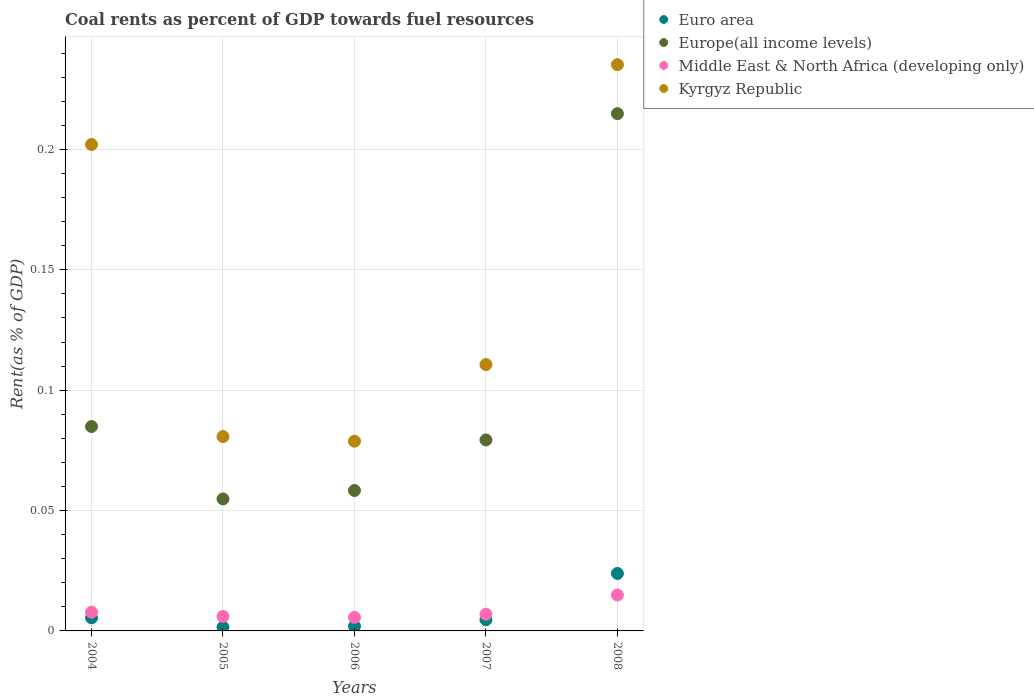Is the number of dotlines equal to the number of legend labels?
Provide a short and direct response. Yes. What is the coal rent in Middle East & North Africa (developing only) in 2005?
Provide a short and direct response. 0.01. Across all years, what is the maximum coal rent in Middle East & North Africa (developing only)?
Offer a terse response. 0.01. Across all years, what is the minimum coal rent in Euro area?
Keep it short and to the point. 0. What is the total coal rent in Middle East & North Africa (developing only) in the graph?
Provide a short and direct response. 0.04. What is the difference between the coal rent in Kyrgyz Republic in 2004 and that in 2007?
Offer a terse response. 0.09. What is the difference between the coal rent in Euro area in 2005 and the coal rent in Kyrgyz Republic in 2007?
Offer a very short reply. -0.11. What is the average coal rent in Kyrgyz Republic per year?
Keep it short and to the point. 0.14. In the year 2006, what is the difference between the coal rent in Europe(all income levels) and coal rent in Middle East & North Africa (developing only)?
Keep it short and to the point. 0.05. What is the ratio of the coal rent in Kyrgyz Republic in 2007 to that in 2008?
Ensure brevity in your answer.  0.47. Is the coal rent in Euro area in 2007 less than that in 2008?
Provide a short and direct response. Yes. Is the difference between the coal rent in Europe(all income levels) in 2005 and 2008 greater than the difference between the coal rent in Middle East & North Africa (developing only) in 2005 and 2008?
Give a very brief answer. No. What is the difference between the highest and the second highest coal rent in Kyrgyz Republic?
Your response must be concise. 0.03. What is the difference between the highest and the lowest coal rent in Middle East & North Africa (developing only)?
Offer a terse response. 0.01. Is it the case that in every year, the sum of the coal rent in Europe(all income levels) and coal rent in Middle East & North Africa (developing only)  is greater than the sum of coal rent in Kyrgyz Republic and coal rent in Euro area?
Give a very brief answer. Yes. Is it the case that in every year, the sum of the coal rent in Euro area and coal rent in Middle East & North Africa (developing only)  is greater than the coal rent in Kyrgyz Republic?
Your answer should be very brief. No. How many years are there in the graph?
Offer a terse response. 5. Are the values on the major ticks of Y-axis written in scientific E-notation?
Provide a succinct answer. No. Does the graph contain any zero values?
Your answer should be very brief. No. Where does the legend appear in the graph?
Ensure brevity in your answer.  Top right. How many legend labels are there?
Your response must be concise. 4. What is the title of the graph?
Provide a short and direct response. Coal rents as percent of GDP towards fuel resources. Does "Sub-Saharan Africa (all income levels)" appear as one of the legend labels in the graph?
Provide a succinct answer. No. What is the label or title of the X-axis?
Keep it short and to the point. Years. What is the label or title of the Y-axis?
Your answer should be compact. Rent(as % of GDP). What is the Rent(as % of GDP) of Euro area in 2004?
Provide a short and direct response. 0.01. What is the Rent(as % of GDP) of Europe(all income levels) in 2004?
Ensure brevity in your answer.  0.08. What is the Rent(as % of GDP) in Middle East & North Africa (developing only) in 2004?
Give a very brief answer. 0.01. What is the Rent(as % of GDP) of Kyrgyz Republic in 2004?
Your answer should be compact. 0.2. What is the Rent(as % of GDP) in Euro area in 2005?
Make the answer very short. 0. What is the Rent(as % of GDP) in Europe(all income levels) in 2005?
Keep it short and to the point. 0.05. What is the Rent(as % of GDP) of Middle East & North Africa (developing only) in 2005?
Offer a terse response. 0.01. What is the Rent(as % of GDP) in Kyrgyz Republic in 2005?
Offer a terse response. 0.08. What is the Rent(as % of GDP) of Euro area in 2006?
Make the answer very short. 0. What is the Rent(as % of GDP) of Europe(all income levels) in 2006?
Your response must be concise. 0.06. What is the Rent(as % of GDP) in Middle East & North Africa (developing only) in 2006?
Provide a short and direct response. 0.01. What is the Rent(as % of GDP) of Kyrgyz Republic in 2006?
Your answer should be compact. 0.08. What is the Rent(as % of GDP) of Euro area in 2007?
Your response must be concise. 0. What is the Rent(as % of GDP) in Europe(all income levels) in 2007?
Make the answer very short. 0.08. What is the Rent(as % of GDP) of Middle East & North Africa (developing only) in 2007?
Your answer should be very brief. 0.01. What is the Rent(as % of GDP) of Kyrgyz Republic in 2007?
Ensure brevity in your answer.  0.11. What is the Rent(as % of GDP) of Euro area in 2008?
Your answer should be compact. 0.02. What is the Rent(as % of GDP) in Europe(all income levels) in 2008?
Your answer should be compact. 0.21. What is the Rent(as % of GDP) of Middle East & North Africa (developing only) in 2008?
Give a very brief answer. 0.01. What is the Rent(as % of GDP) in Kyrgyz Republic in 2008?
Your answer should be very brief. 0.24. Across all years, what is the maximum Rent(as % of GDP) of Euro area?
Ensure brevity in your answer.  0.02. Across all years, what is the maximum Rent(as % of GDP) in Europe(all income levels)?
Provide a succinct answer. 0.21. Across all years, what is the maximum Rent(as % of GDP) of Middle East & North Africa (developing only)?
Offer a very short reply. 0.01. Across all years, what is the maximum Rent(as % of GDP) in Kyrgyz Republic?
Ensure brevity in your answer.  0.24. Across all years, what is the minimum Rent(as % of GDP) in Euro area?
Offer a very short reply. 0. Across all years, what is the minimum Rent(as % of GDP) in Europe(all income levels)?
Your response must be concise. 0.05. Across all years, what is the minimum Rent(as % of GDP) of Middle East & North Africa (developing only)?
Provide a short and direct response. 0.01. Across all years, what is the minimum Rent(as % of GDP) of Kyrgyz Republic?
Give a very brief answer. 0.08. What is the total Rent(as % of GDP) in Euro area in the graph?
Provide a succinct answer. 0.04. What is the total Rent(as % of GDP) of Europe(all income levels) in the graph?
Offer a very short reply. 0.49. What is the total Rent(as % of GDP) of Middle East & North Africa (developing only) in the graph?
Provide a succinct answer. 0.04. What is the total Rent(as % of GDP) of Kyrgyz Republic in the graph?
Ensure brevity in your answer.  0.71. What is the difference between the Rent(as % of GDP) in Euro area in 2004 and that in 2005?
Your answer should be very brief. 0. What is the difference between the Rent(as % of GDP) of Europe(all income levels) in 2004 and that in 2005?
Your answer should be compact. 0.03. What is the difference between the Rent(as % of GDP) in Middle East & North Africa (developing only) in 2004 and that in 2005?
Your response must be concise. 0. What is the difference between the Rent(as % of GDP) in Kyrgyz Republic in 2004 and that in 2005?
Ensure brevity in your answer.  0.12. What is the difference between the Rent(as % of GDP) in Euro area in 2004 and that in 2006?
Your answer should be very brief. 0. What is the difference between the Rent(as % of GDP) of Europe(all income levels) in 2004 and that in 2006?
Provide a succinct answer. 0.03. What is the difference between the Rent(as % of GDP) of Middle East & North Africa (developing only) in 2004 and that in 2006?
Offer a very short reply. 0. What is the difference between the Rent(as % of GDP) of Kyrgyz Republic in 2004 and that in 2006?
Offer a very short reply. 0.12. What is the difference between the Rent(as % of GDP) in Euro area in 2004 and that in 2007?
Provide a short and direct response. 0. What is the difference between the Rent(as % of GDP) in Europe(all income levels) in 2004 and that in 2007?
Give a very brief answer. 0.01. What is the difference between the Rent(as % of GDP) of Middle East & North Africa (developing only) in 2004 and that in 2007?
Make the answer very short. 0. What is the difference between the Rent(as % of GDP) of Kyrgyz Republic in 2004 and that in 2007?
Give a very brief answer. 0.09. What is the difference between the Rent(as % of GDP) of Euro area in 2004 and that in 2008?
Offer a terse response. -0.02. What is the difference between the Rent(as % of GDP) of Europe(all income levels) in 2004 and that in 2008?
Your response must be concise. -0.13. What is the difference between the Rent(as % of GDP) of Middle East & North Africa (developing only) in 2004 and that in 2008?
Your response must be concise. -0.01. What is the difference between the Rent(as % of GDP) in Kyrgyz Republic in 2004 and that in 2008?
Ensure brevity in your answer.  -0.03. What is the difference between the Rent(as % of GDP) in Euro area in 2005 and that in 2006?
Your answer should be very brief. -0. What is the difference between the Rent(as % of GDP) in Europe(all income levels) in 2005 and that in 2006?
Your answer should be compact. -0. What is the difference between the Rent(as % of GDP) in Kyrgyz Republic in 2005 and that in 2006?
Provide a short and direct response. 0. What is the difference between the Rent(as % of GDP) of Euro area in 2005 and that in 2007?
Your answer should be very brief. -0. What is the difference between the Rent(as % of GDP) in Europe(all income levels) in 2005 and that in 2007?
Offer a terse response. -0.02. What is the difference between the Rent(as % of GDP) in Middle East & North Africa (developing only) in 2005 and that in 2007?
Your answer should be very brief. -0. What is the difference between the Rent(as % of GDP) in Kyrgyz Republic in 2005 and that in 2007?
Provide a short and direct response. -0.03. What is the difference between the Rent(as % of GDP) of Euro area in 2005 and that in 2008?
Give a very brief answer. -0.02. What is the difference between the Rent(as % of GDP) of Europe(all income levels) in 2005 and that in 2008?
Keep it short and to the point. -0.16. What is the difference between the Rent(as % of GDP) in Middle East & North Africa (developing only) in 2005 and that in 2008?
Provide a succinct answer. -0.01. What is the difference between the Rent(as % of GDP) of Kyrgyz Republic in 2005 and that in 2008?
Provide a short and direct response. -0.15. What is the difference between the Rent(as % of GDP) of Euro area in 2006 and that in 2007?
Ensure brevity in your answer.  -0. What is the difference between the Rent(as % of GDP) of Europe(all income levels) in 2006 and that in 2007?
Offer a terse response. -0.02. What is the difference between the Rent(as % of GDP) in Middle East & North Africa (developing only) in 2006 and that in 2007?
Provide a succinct answer. -0. What is the difference between the Rent(as % of GDP) of Kyrgyz Republic in 2006 and that in 2007?
Your answer should be compact. -0.03. What is the difference between the Rent(as % of GDP) of Euro area in 2006 and that in 2008?
Give a very brief answer. -0.02. What is the difference between the Rent(as % of GDP) in Europe(all income levels) in 2006 and that in 2008?
Your answer should be very brief. -0.16. What is the difference between the Rent(as % of GDP) of Middle East & North Africa (developing only) in 2006 and that in 2008?
Provide a short and direct response. -0.01. What is the difference between the Rent(as % of GDP) in Kyrgyz Republic in 2006 and that in 2008?
Make the answer very short. -0.16. What is the difference between the Rent(as % of GDP) of Euro area in 2007 and that in 2008?
Offer a very short reply. -0.02. What is the difference between the Rent(as % of GDP) of Europe(all income levels) in 2007 and that in 2008?
Give a very brief answer. -0.14. What is the difference between the Rent(as % of GDP) in Middle East & North Africa (developing only) in 2007 and that in 2008?
Your response must be concise. -0.01. What is the difference between the Rent(as % of GDP) of Kyrgyz Republic in 2007 and that in 2008?
Your answer should be very brief. -0.12. What is the difference between the Rent(as % of GDP) of Euro area in 2004 and the Rent(as % of GDP) of Europe(all income levels) in 2005?
Your response must be concise. -0.05. What is the difference between the Rent(as % of GDP) of Euro area in 2004 and the Rent(as % of GDP) of Middle East & North Africa (developing only) in 2005?
Offer a terse response. -0. What is the difference between the Rent(as % of GDP) in Euro area in 2004 and the Rent(as % of GDP) in Kyrgyz Republic in 2005?
Keep it short and to the point. -0.08. What is the difference between the Rent(as % of GDP) of Europe(all income levels) in 2004 and the Rent(as % of GDP) of Middle East & North Africa (developing only) in 2005?
Provide a succinct answer. 0.08. What is the difference between the Rent(as % of GDP) in Europe(all income levels) in 2004 and the Rent(as % of GDP) in Kyrgyz Republic in 2005?
Ensure brevity in your answer.  0. What is the difference between the Rent(as % of GDP) in Middle East & North Africa (developing only) in 2004 and the Rent(as % of GDP) in Kyrgyz Republic in 2005?
Provide a succinct answer. -0.07. What is the difference between the Rent(as % of GDP) in Euro area in 2004 and the Rent(as % of GDP) in Europe(all income levels) in 2006?
Make the answer very short. -0.05. What is the difference between the Rent(as % of GDP) in Euro area in 2004 and the Rent(as % of GDP) in Middle East & North Africa (developing only) in 2006?
Make the answer very short. -0. What is the difference between the Rent(as % of GDP) of Euro area in 2004 and the Rent(as % of GDP) of Kyrgyz Republic in 2006?
Offer a very short reply. -0.07. What is the difference between the Rent(as % of GDP) in Europe(all income levels) in 2004 and the Rent(as % of GDP) in Middle East & North Africa (developing only) in 2006?
Make the answer very short. 0.08. What is the difference between the Rent(as % of GDP) of Europe(all income levels) in 2004 and the Rent(as % of GDP) of Kyrgyz Republic in 2006?
Offer a terse response. 0.01. What is the difference between the Rent(as % of GDP) of Middle East & North Africa (developing only) in 2004 and the Rent(as % of GDP) of Kyrgyz Republic in 2006?
Offer a terse response. -0.07. What is the difference between the Rent(as % of GDP) of Euro area in 2004 and the Rent(as % of GDP) of Europe(all income levels) in 2007?
Keep it short and to the point. -0.07. What is the difference between the Rent(as % of GDP) in Euro area in 2004 and the Rent(as % of GDP) in Middle East & North Africa (developing only) in 2007?
Your answer should be very brief. -0. What is the difference between the Rent(as % of GDP) of Euro area in 2004 and the Rent(as % of GDP) of Kyrgyz Republic in 2007?
Your response must be concise. -0.11. What is the difference between the Rent(as % of GDP) in Europe(all income levels) in 2004 and the Rent(as % of GDP) in Middle East & North Africa (developing only) in 2007?
Keep it short and to the point. 0.08. What is the difference between the Rent(as % of GDP) in Europe(all income levels) in 2004 and the Rent(as % of GDP) in Kyrgyz Republic in 2007?
Keep it short and to the point. -0.03. What is the difference between the Rent(as % of GDP) in Middle East & North Africa (developing only) in 2004 and the Rent(as % of GDP) in Kyrgyz Republic in 2007?
Offer a terse response. -0.1. What is the difference between the Rent(as % of GDP) of Euro area in 2004 and the Rent(as % of GDP) of Europe(all income levels) in 2008?
Provide a short and direct response. -0.21. What is the difference between the Rent(as % of GDP) of Euro area in 2004 and the Rent(as % of GDP) of Middle East & North Africa (developing only) in 2008?
Your answer should be very brief. -0.01. What is the difference between the Rent(as % of GDP) of Euro area in 2004 and the Rent(as % of GDP) of Kyrgyz Republic in 2008?
Make the answer very short. -0.23. What is the difference between the Rent(as % of GDP) in Europe(all income levels) in 2004 and the Rent(as % of GDP) in Middle East & North Africa (developing only) in 2008?
Ensure brevity in your answer.  0.07. What is the difference between the Rent(as % of GDP) in Europe(all income levels) in 2004 and the Rent(as % of GDP) in Kyrgyz Republic in 2008?
Provide a succinct answer. -0.15. What is the difference between the Rent(as % of GDP) in Middle East & North Africa (developing only) in 2004 and the Rent(as % of GDP) in Kyrgyz Republic in 2008?
Offer a very short reply. -0.23. What is the difference between the Rent(as % of GDP) in Euro area in 2005 and the Rent(as % of GDP) in Europe(all income levels) in 2006?
Your answer should be very brief. -0.06. What is the difference between the Rent(as % of GDP) of Euro area in 2005 and the Rent(as % of GDP) of Middle East & North Africa (developing only) in 2006?
Your response must be concise. -0. What is the difference between the Rent(as % of GDP) of Euro area in 2005 and the Rent(as % of GDP) of Kyrgyz Republic in 2006?
Provide a short and direct response. -0.08. What is the difference between the Rent(as % of GDP) in Europe(all income levels) in 2005 and the Rent(as % of GDP) in Middle East & North Africa (developing only) in 2006?
Your answer should be very brief. 0.05. What is the difference between the Rent(as % of GDP) in Europe(all income levels) in 2005 and the Rent(as % of GDP) in Kyrgyz Republic in 2006?
Ensure brevity in your answer.  -0.02. What is the difference between the Rent(as % of GDP) of Middle East & North Africa (developing only) in 2005 and the Rent(as % of GDP) of Kyrgyz Republic in 2006?
Offer a very short reply. -0.07. What is the difference between the Rent(as % of GDP) of Euro area in 2005 and the Rent(as % of GDP) of Europe(all income levels) in 2007?
Offer a very short reply. -0.08. What is the difference between the Rent(as % of GDP) in Euro area in 2005 and the Rent(as % of GDP) in Middle East & North Africa (developing only) in 2007?
Ensure brevity in your answer.  -0.01. What is the difference between the Rent(as % of GDP) of Euro area in 2005 and the Rent(as % of GDP) of Kyrgyz Republic in 2007?
Provide a succinct answer. -0.11. What is the difference between the Rent(as % of GDP) of Europe(all income levels) in 2005 and the Rent(as % of GDP) of Middle East & North Africa (developing only) in 2007?
Your answer should be very brief. 0.05. What is the difference between the Rent(as % of GDP) in Europe(all income levels) in 2005 and the Rent(as % of GDP) in Kyrgyz Republic in 2007?
Ensure brevity in your answer.  -0.06. What is the difference between the Rent(as % of GDP) of Middle East & North Africa (developing only) in 2005 and the Rent(as % of GDP) of Kyrgyz Republic in 2007?
Keep it short and to the point. -0.1. What is the difference between the Rent(as % of GDP) in Euro area in 2005 and the Rent(as % of GDP) in Europe(all income levels) in 2008?
Keep it short and to the point. -0.21. What is the difference between the Rent(as % of GDP) of Euro area in 2005 and the Rent(as % of GDP) of Middle East & North Africa (developing only) in 2008?
Provide a short and direct response. -0.01. What is the difference between the Rent(as % of GDP) of Euro area in 2005 and the Rent(as % of GDP) of Kyrgyz Republic in 2008?
Your answer should be compact. -0.23. What is the difference between the Rent(as % of GDP) of Europe(all income levels) in 2005 and the Rent(as % of GDP) of Middle East & North Africa (developing only) in 2008?
Make the answer very short. 0.04. What is the difference between the Rent(as % of GDP) in Europe(all income levels) in 2005 and the Rent(as % of GDP) in Kyrgyz Republic in 2008?
Offer a very short reply. -0.18. What is the difference between the Rent(as % of GDP) in Middle East & North Africa (developing only) in 2005 and the Rent(as % of GDP) in Kyrgyz Republic in 2008?
Offer a terse response. -0.23. What is the difference between the Rent(as % of GDP) in Euro area in 2006 and the Rent(as % of GDP) in Europe(all income levels) in 2007?
Offer a terse response. -0.08. What is the difference between the Rent(as % of GDP) of Euro area in 2006 and the Rent(as % of GDP) of Middle East & North Africa (developing only) in 2007?
Provide a succinct answer. -0.01. What is the difference between the Rent(as % of GDP) in Euro area in 2006 and the Rent(as % of GDP) in Kyrgyz Republic in 2007?
Keep it short and to the point. -0.11. What is the difference between the Rent(as % of GDP) of Europe(all income levels) in 2006 and the Rent(as % of GDP) of Middle East & North Africa (developing only) in 2007?
Your response must be concise. 0.05. What is the difference between the Rent(as % of GDP) of Europe(all income levels) in 2006 and the Rent(as % of GDP) of Kyrgyz Republic in 2007?
Give a very brief answer. -0.05. What is the difference between the Rent(as % of GDP) in Middle East & North Africa (developing only) in 2006 and the Rent(as % of GDP) in Kyrgyz Republic in 2007?
Make the answer very short. -0.1. What is the difference between the Rent(as % of GDP) of Euro area in 2006 and the Rent(as % of GDP) of Europe(all income levels) in 2008?
Keep it short and to the point. -0.21. What is the difference between the Rent(as % of GDP) of Euro area in 2006 and the Rent(as % of GDP) of Middle East & North Africa (developing only) in 2008?
Provide a short and direct response. -0.01. What is the difference between the Rent(as % of GDP) in Euro area in 2006 and the Rent(as % of GDP) in Kyrgyz Republic in 2008?
Give a very brief answer. -0.23. What is the difference between the Rent(as % of GDP) of Europe(all income levels) in 2006 and the Rent(as % of GDP) of Middle East & North Africa (developing only) in 2008?
Offer a terse response. 0.04. What is the difference between the Rent(as % of GDP) of Europe(all income levels) in 2006 and the Rent(as % of GDP) of Kyrgyz Republic in 2008?
Offer a very short reply. -0.18. What is the difference between the Rent(as % of GDP) of Middle East & North Africa (developing only) in 2006 and the Rent(as % of GDP) of Kyrgyz Republic in 2008?
Your answer should be very brief. -0.23. What is the difference between the Rent(as % of GDP) of Euro area in 2007 and the Rent(as % of GDP) of Europe(all income levels) in 2008?
Offer a terse response. -0.21. What is the difference between the Rent(as % of GDP) of Euro area in 2007 and the Rent(as % of GDP) of Middle East & North Africa (developing only) in 2008?
Provide a short and direct response. -0.01. What is the difference between the Rent(as % of GDP) in Euro area in 2007 and the Rent(as % of GDP) in Kyrgyz Republic in 2008?
Give a very brief answer. -0.23. What is the difference between the Rent(as % of GDP) of Europe(all income levels) in 2007 and the Rent(as % of GDP) of Middle East & North Africa (developing only) in 2008?
Provide a short and direct response. 0.06. What is the difference between the Rent(as % of GDP) of Europe(all income levels) in 2007 and the Rent(as % of GDP) of Kyrgyz Republic in 2008?
Offer a very short reply. -0.16. What is the difference between the Rent(as % of GDP) in Middle East & North Africa (developing only) in 2007 and the Rent(as % of GDP) in Kyrgyz Republic in 2008?
Provide a short and direct response. -0.23. What is the average Rent(as % of GDP) of Euro area per year?
Offer a terse response. 0.01. What is the average Rent(as % of GDP) of Europe(all income levels) per year?
Your response must be concise. 0.1. What is the average Rent(as % of GDP) in Middle East & North Africa (developing only) per year?
Keep it short and to the point. 0.01. What is the average Rent(as % of GDP) of Kyrgyz Republic per year?
Offer a terse response. 0.14. In the year 2004, what is the difference between the Rent(as % of GDP) in Euro area and Rent(as % of GDP) in Europe(all income levels)?
Make the answer very short. -0.08. In the year 2004, what is the difference between the Rent(as % of GDP) of Euro area and Rent(as % of GDP) of Middle East & North Africa (developing only)?
Keep it short and to the point. -0. In the year 2004, what is the difference between the Rent(as % of GDP) of Euro area and Rent(as % of GDP) of Kyrgyz Republic?
Keep it short and to the point. -0.2. In the year 2004, what is the difference between the Rent(as % of GDP) in Europe(all income levels) and Rent(as % of GDP) in Middle East & North Africa (developing only)?
Offer a very short reply. 0.08. In the year 2004, what is the difference between the Rent(as % of GDP) of Europe(all income levels) and Rent(as % of GDP) of Kyrgyz Republic?
Provide a short and direct response. -0.12. In the year 2004, what is the difference between the Rent(as % of GDP) of Middle East & North Africa (developing only) and Rent(as % of GDP) of Kyrgyz Republic?
Your response must be concise. -0.19. In the year 2005, what is the difference between the Rent(as % of GDP) of Euro area and Rent(as % of GDP) of Europe(all income levels)?
Ensure brevity in your answer.  -0.05. In the year 2005, what is the difference between the Rent(as % of GDP) in Euro area and Rent(as % of GDP) in Middle East & North Africa (developing only)?
Offer a very short reply. -0. In the year 2005, what is the difference between the Rent(as % of GDP) of Euro area and Rent(as % of GDP) of Kyrgyz Republic?
Keep it short and to the point. -0.08. In the year 2005, what is the difference between the Rent(as % of GDP) in Europe(all income levels) and Rent(as % of GDP) in Middle East & North Africa (developing only)?
Make the answer very short. 0.05. In the year 2005, what is the difference between the Rent(as % of GDP) in Europe(all income levels) and Rent(as % of GDP) in Kyrgyz Republic?
Your answer should be very brief. -0.03. In the year 2005, what is the difference between the Rent(as % of GDP) in Middle East & North Africa (developing only) and Rent(as % of GDP) in Kyrgyz Republic?
Keep it short and to the point. -0.07. In the year 2006, what is the difference between the Rent(as % of GDP) of Euro area and Rent(as % of GDP) of Europe(all income levels)?
Offer a terse response. -0.06. In the year 2006, what is the difference between the Rent(as % of GDP) in Euro area and Rent(as % of GDP) in Middle East & North Africa (developing only)?
Provide a succinct answer. -0. In the year 2006, what is the difference between the Rent(as % of GDP) in Euro area and Rent(as % of GDP) in Kyrgyz Republic?
Make the answer very short. -0.08. In the year 2006, what is the difference between the Rent(as % of GDP) in Europe(all income levels) and Rent(as % of GDP) in Middle East & North Africa (developing only)?
Provide a succinct answer. 0.05. In the year 2006, what is the difference between the Rent(as % of GDP) of Europe(all income levels) and Rent(as % of GDP) of Kyrgyz Republic?
Keep it short and to the point. -0.02. In the year 2006, what is the difference between the Rent(as % of GDP) of Middle East & North Africa (developing only) and Rent(as % of GDP) of Kyrgyz Republic?
Your answer should be compact. -0.07. In the year 2007, what is the difference between the Rent(as % of GDP) of Euro area and Rent(as % of GDP) of Europe(all income levels)?
Offer a terse response. -0.07. In the year 2007, what is the difference between the Rent(as % of GDP) of Euro area and Rent(as % of GDP) of Middle East & North Africa (developing only)?
Provide a short and direct response. -0. In the year 2007, what is the difference between the Rent(as % of GDP) of Euro area and Rent(as % of GDP) of Kyrgyz Republic?
Give a very brief answer. -0.11. In the year 2007, what is the difference between the Rent(as % of GDP) in Europe(all income levels) and Rent(as % of GDP) in Middle East & North Africa (developing only)?
Make the answer very short. 0.07. In the year 2007, what is the difference between the Rent(as % of GDP) of Europe(all income levels) and Rent(as % of GDP) of Kyrgyz Republic?
Offer a very short reply. -0.03. In the year 2007, what is the difference between the Rent(as % of GDP) of Middle East & North Africa (developing only) and Rent(as % of GDP) of Kyrgyz Republic?
Your response must be concise. -0.1. In the year 2008, what is the difference between the Rent(as % of GDP) of Euro area and Rent(as % of GDP) of Europe(all income levels)?
Your response must be concise. -0.19. In the year 2008, what is the difference between the Rent(as % of GDP) of Euro area and Rent(as % of GDP) of Middle East & North Africa (developing only)?
Keep it short and to the point. 0.01. In the year 2008, what is the difference between the Rent(as % of GDP) in Euro area and Rent(as % of GDP) in Kyrgyz Republic?
Your answer should be compact. -0.21. In the year 2008, what is the difference between the Rent(as % of GDP) in Europe(all income levels) and Rent(as % of GDP) in Middle East & North Africa (developing only)?
Give a very brief answer. 0.2. In the year 2008, what is the difference between the Rent(as % of GDP) of Europe(all income levels) and Rent(as % of GDP) of Kyrgyz Republic?
Ensure brevity in your answer.  -0.02. In the year 2008, what is the difference between the Rent(as % of GDP) in Middle East & North Africa (developing only) and Rent(as % of GDP) in Kyrgyz Republic?
Ensure brevity in your answer.  -0.22. What is the ratio of the Rent(as % of GDP) in Euro area in 2004 to that in 2005?
Provide a short and direct response. 3.44. What is the ratio of the Rent(as % of GDP) in Europe(all income levels) in 2004 to that in 2005?
Your response must be concise. 1.55. What is the ratio of the Rent(as % of GDP) of Middle East & North Africa (developing only) in 2004 to that in 2005?
Your answer should be compact. 1.29. What is the ratio of the Rent(as % of GDP) in Kyrgyz Republic in 2004 to that in 2005?
Your answer should be very brief. 2.5. What is the ratio of the Rent(as % of GDP) of Euro area in 2004 to that in 2006?
Provide a short and direct response. 2.81. What is the ratio of the Rent(as % of GDP) of Europe(all income levels) in 2004 to that in 2006?
Your response must be concise. 1.46. What is the ratio of the Rent(as % of GDP) of Middle East & North Africa (developing only) in 2004 to that in 2006?
Your answer should be compact. 1.39. What is the ratio of the Rent(as % of GDP) of Kyrgyz Republic in 2004 to that in 2006?
Make the answer very short. 2.56. What is the ratio of the Rent(as % of GDP) of Euro area in 2004 to that in 2007?
Give a very brief answer. 1.16. What is the ratio of the Rent(as % of GDP) of Europe(all income levels) in 2004 to that in 2007?
Provide a succinct answer. 1.07. What is the ratio of the Rent(as % of GDP) in Middle East & North Africa (developing only) in 2004 to that in 2007?
Give a very brief answer. 1.12. What is the ratio of the Rent(as % of GDP) in Kyrgyz Republic in 2004 to that in 2007?
Give a very brief answer. 1.83. What is the ratio of the Rent(as % of GDP) in Euro area in 2004 to that in 2008?
Keep it short and to the point. 0.23. What is the ratio of the Rent(as % of GDP) of Europe(all income levels) in 2004 to that in 2008?
Provide a short and direct response. 0.4. What is the ratio of the Rent(as % of GDP) of Middle East & North Africa (developing only) in 2004 to that in 2008?
Ensure brevity in your answer.  0.52. What is the ratio of the Rent(as % of GDP) of Kyrgyz Republic in 2004 to that in 2008?
Your response must be concise. 0.86. What is the ratio of the Rent(as % of GDP) in Euro area in 2005 to that in 2006?
Provide a succinct answer. 0.82. What is the ratio of the Rent(as % of GDP) in Europe(all income levels) in 2005 to that in 2006?
Provide a short and direct response. 0.94. What is the ratio of the Rent(as % of GDP) in Middle East & North Africa (developing only) in 2005 to that in 2006?
Your answer should be compact. 1.07. What is the ratio of the Rent(as % of GDP) in Kyrgyz Republic in 2005 to that in 2006?
Your answer should be very brief. 1.02. What is the ratio of the Rent(as % of GDP) in Euro area in 2005 to that in 2007?
Provide a short and direct response. 0.34. What is the ratio of the Rent(as % of GDP) in Europe(all income levels) in 2005 to that in 2007?
Make the answer very short. 0.69. What is the ratio of the Rent(as % of GDP) of Middle East & North Africa (developing only) in 2005 to that in 2007?
Your answer should be compact. 0.87. What is the ratio of the Rent(as % of GDP) in Kyrgyz Republic in 2005 to that in 2007?
Your answer should be compact. 0.73. What is the ratio of the Rent(as % of GDP) in Euro area in 2005 to that in 2008?
Ensure brevity in your answer.  0.07. What is the ratio of the Rent(as % of GDP) of Europe(all income levels) in 2005 to that in 2008?
Ensure brevity in your answer.  0.26. What is the ratio of the Rent(as % of GDP) in Middle East & North Africa (developing only) in 2005 to that in 2008?
Your answer should be very brief. 0.4. What is the ratio of the Rent(as % of GDP) of Kyrgyz Republic in 2005 to that in 2008?
Make the answer very short. 0.34. What is the ratio of the Rent(as % of GDP) in Euro area in 2006 to that in 2007?
Your answer should be very brief. 0.41. What is the ratio of the Rent(as % of GDP) of Europe(all income levels) in 2006 to that in 2007?
Your response must be concise. 0.74. What is the ratio of the Rent(as % of GDP) of Middle East & North Africa (developing only) in 2006 to that in 2007?
Keep it short and to the point. 0.81. What is the ratio of the Rent(as % of GDP) in Kyrgyz Republic in 2006 to that in 2007?
Provide a succinct answer. 0.71. What is the ratio of the Rent(as % of GDP) of Euro area in 2006 to that in 2008?
Give a very brief answer. 0.08. What is the ratio of the Rent(as % of GDP) of Europe(all income levels) in 2006 to that in 2008?
Provide a short and direct response. 0.27. What is the ratio of the Rent(as % of GDP) in Middle East & North Africa (developing only) in 2006 to that in 2008?
Give a very brief answer. 0.38. What is the ratio of the Rent(as % of GDP) in Kyrgyz Republic in 2006 to that in 2008?
Your answer should be compact. 0.34. What is the ratio of the Rent(as % of GDP) of Euro area in 2007 to that in 2008?
Your answer should be compact. 0.2. What is the ratio of the Rent(as % of GDP) of Europe(all income levels) in 2007 to that in 2008?
Give a very brief answer. 0.37. What is the ratio of the Rent(as % of GDP) of Middle East & North Africa (developing only) in 2007 to that in 2008?
Your answer should be compact. 0.47. What is the ratio of the Rent(as % of GDP) in Kyrgyz Republic in 2007 to that in 2008?
Ensure brevity in your answer.  0.47. What is the difference between the highest and the second highest Rent(as % of GDP) of Euro area?
Your response must be concise. 0.02. What is the difference between the highest and the second highest Rent(as % of GDP) of Europe(all income levels)?
Offer a terse response. 0.13. What is the difference between the highest and the second highest Rent(as % of GDP) of Middle East & North Africa (developing only)?
Your response must be concise. 0.01. What is the difference between the highest and the second highest Rent(as % of GDP) in Kyrgyz Republic?
Your answer should be compact. 0.03. What is the difference between the highest and the lowest Rent(as % of GDP) in Euro area?
Provide a succinct answer. 0.02. What is the difference between the highest and the lowest Rent(as % of GDP) of Europe(all income levels)?
Offer a terse response. 0.16. What is the difference between the highest and the lowest Rent(as % of GDP) of Middle East & North Africa (developing only)?
Provide a succinct answer. 0.01. What is the difference between the highest and the lowest Rent(as % of GDP) in Kyrgyz Republic?
Your answer should be compact. 0.16. 